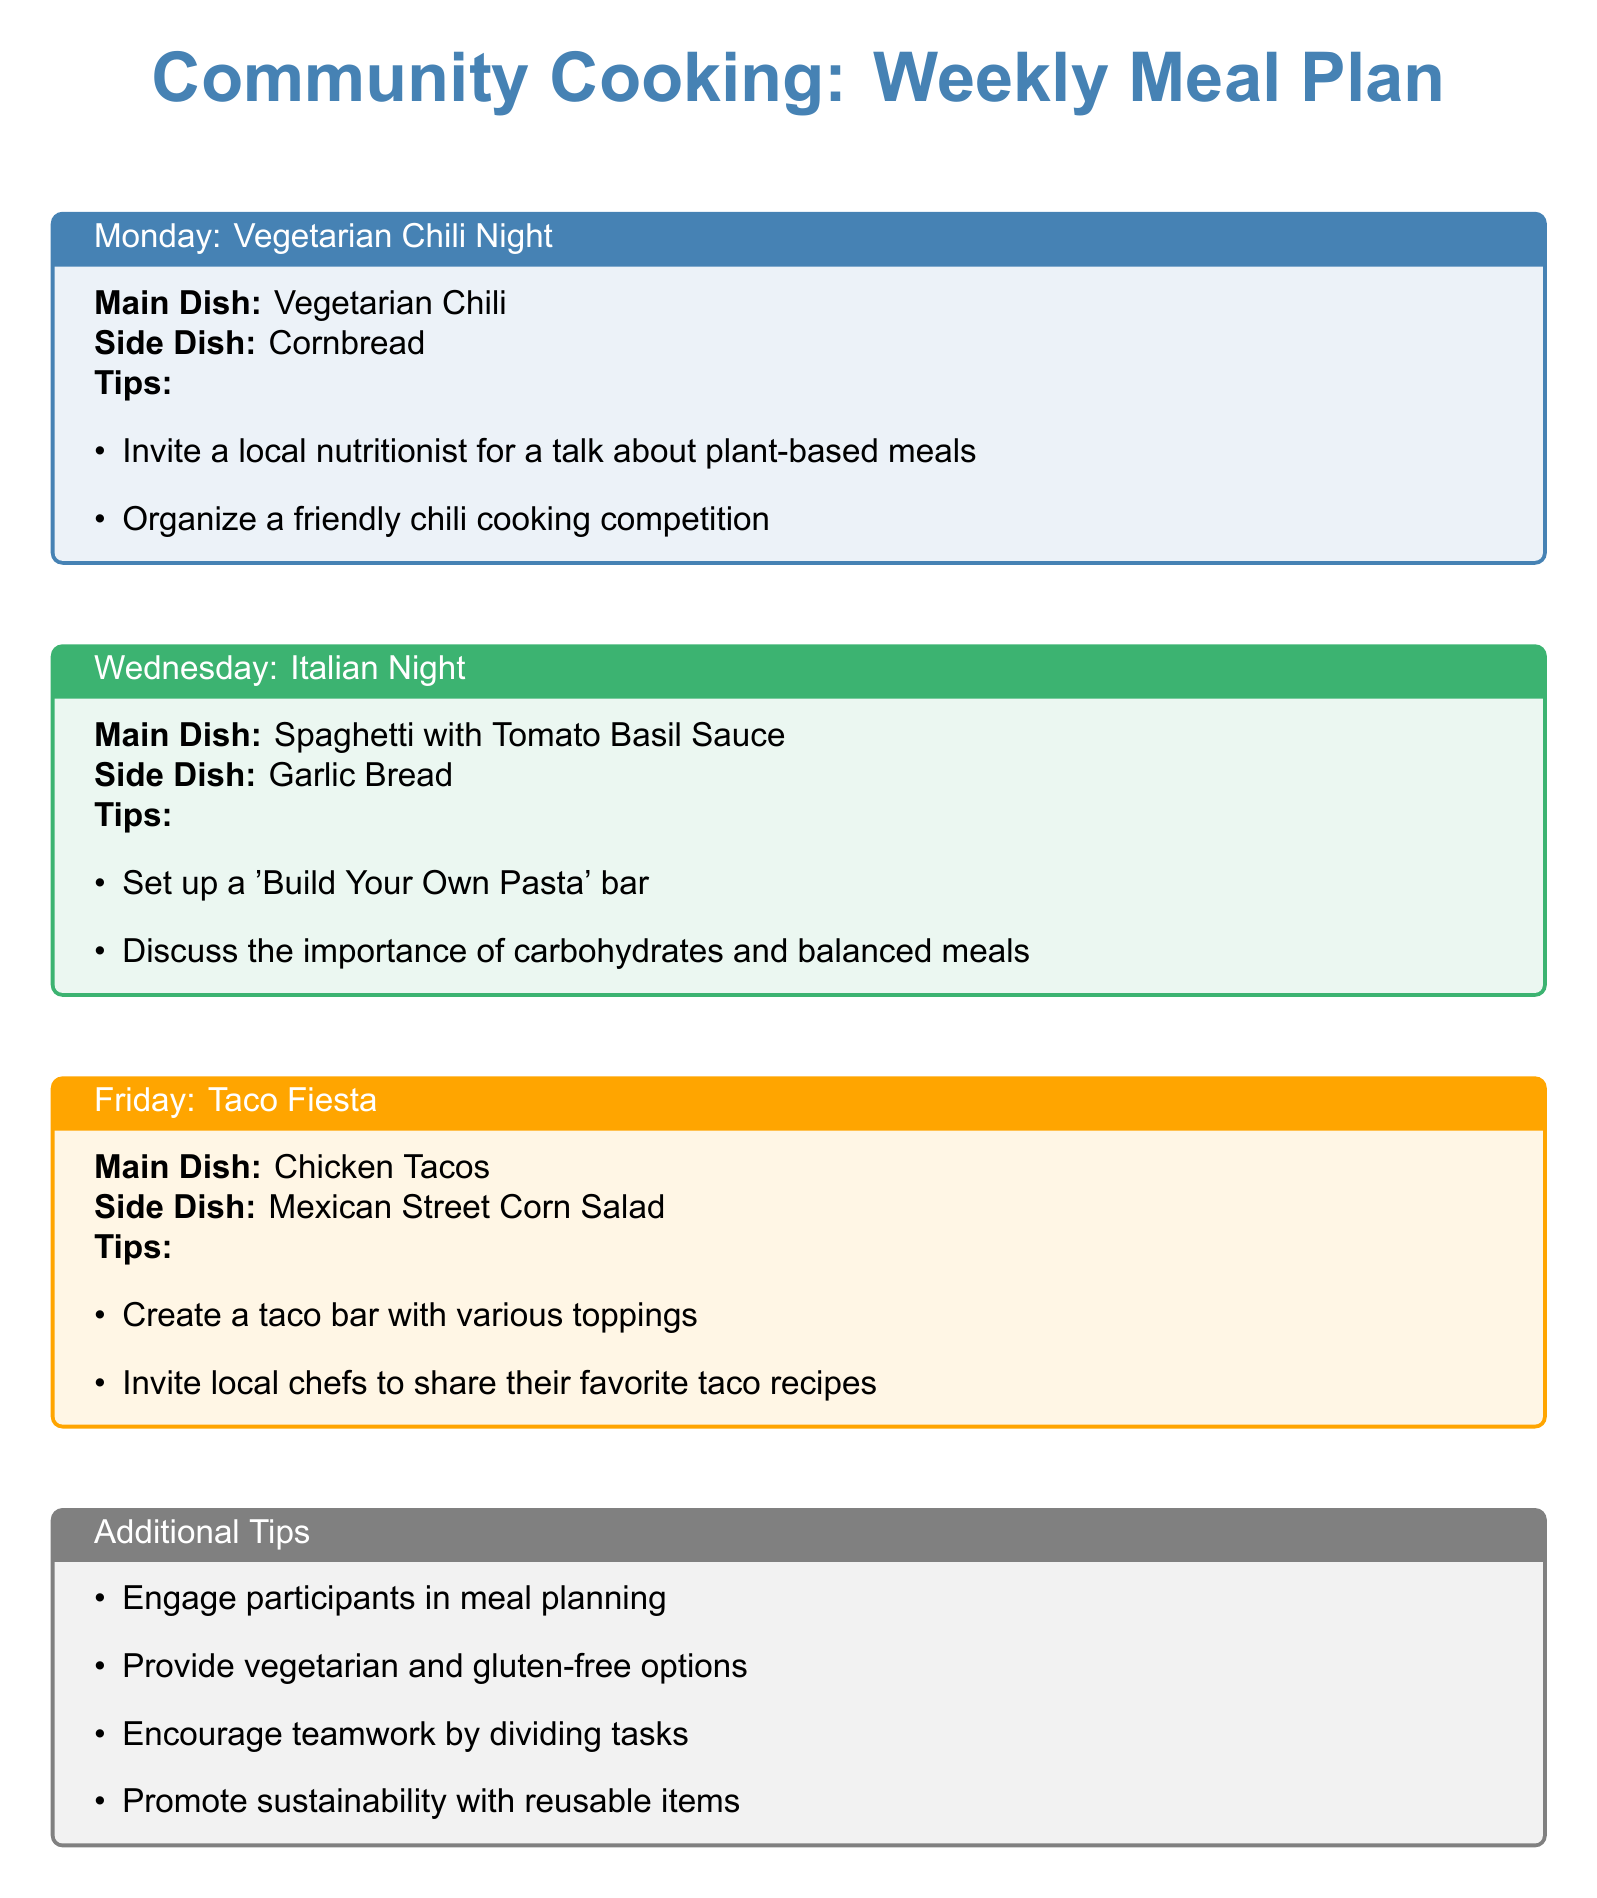What is the main dish on Monday? The main dish on Monday is mentioned in the document, which states "Main Dish: Vegetarian Chili."
Answer: Vegetarian Chili What side dish is served with the Chicken Tacos? The document specifies the side dish that accompanies Chicken Tacos, which is "Mexican Street Corn Salad."
Answer: Mexican Street Corn Salad Who can be invited to talk about plant-based meals? According to the tips on Monday, it suggests inviting a "local nutritionist" for a talk.
Answer: Local nutritionist What is a suggestion for Wednesday's meal plan? The document provides a suggestion which states to "Set up a 'Build Your Own Pasta' bar."
Answer: Build Your Own Pasta bar How many main dishes are mentioned in the meal plan? The meal plan outlines three days with main dishes, which can be counted from the text.
Answer: 3 What is a tip mentioned for promoting teamwork? The document notes a tip to "Encourage teamwork by dividing tasks" to promote cooperation.
Answer: Dividing tasks What is the color theme for Friday's meal plan box? The color assigned for Friday's meal plan box is described as "myorange."
Answer: My orange What type of meal does the plan include on Wednesday? The plan specifically notes Wednesday's meal type as "Italian Night."
Answer: Italian Night 